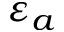<formula> <loc_0><loc_0><loc_500><loc_500>\varepsilon _ { a }</formula> 